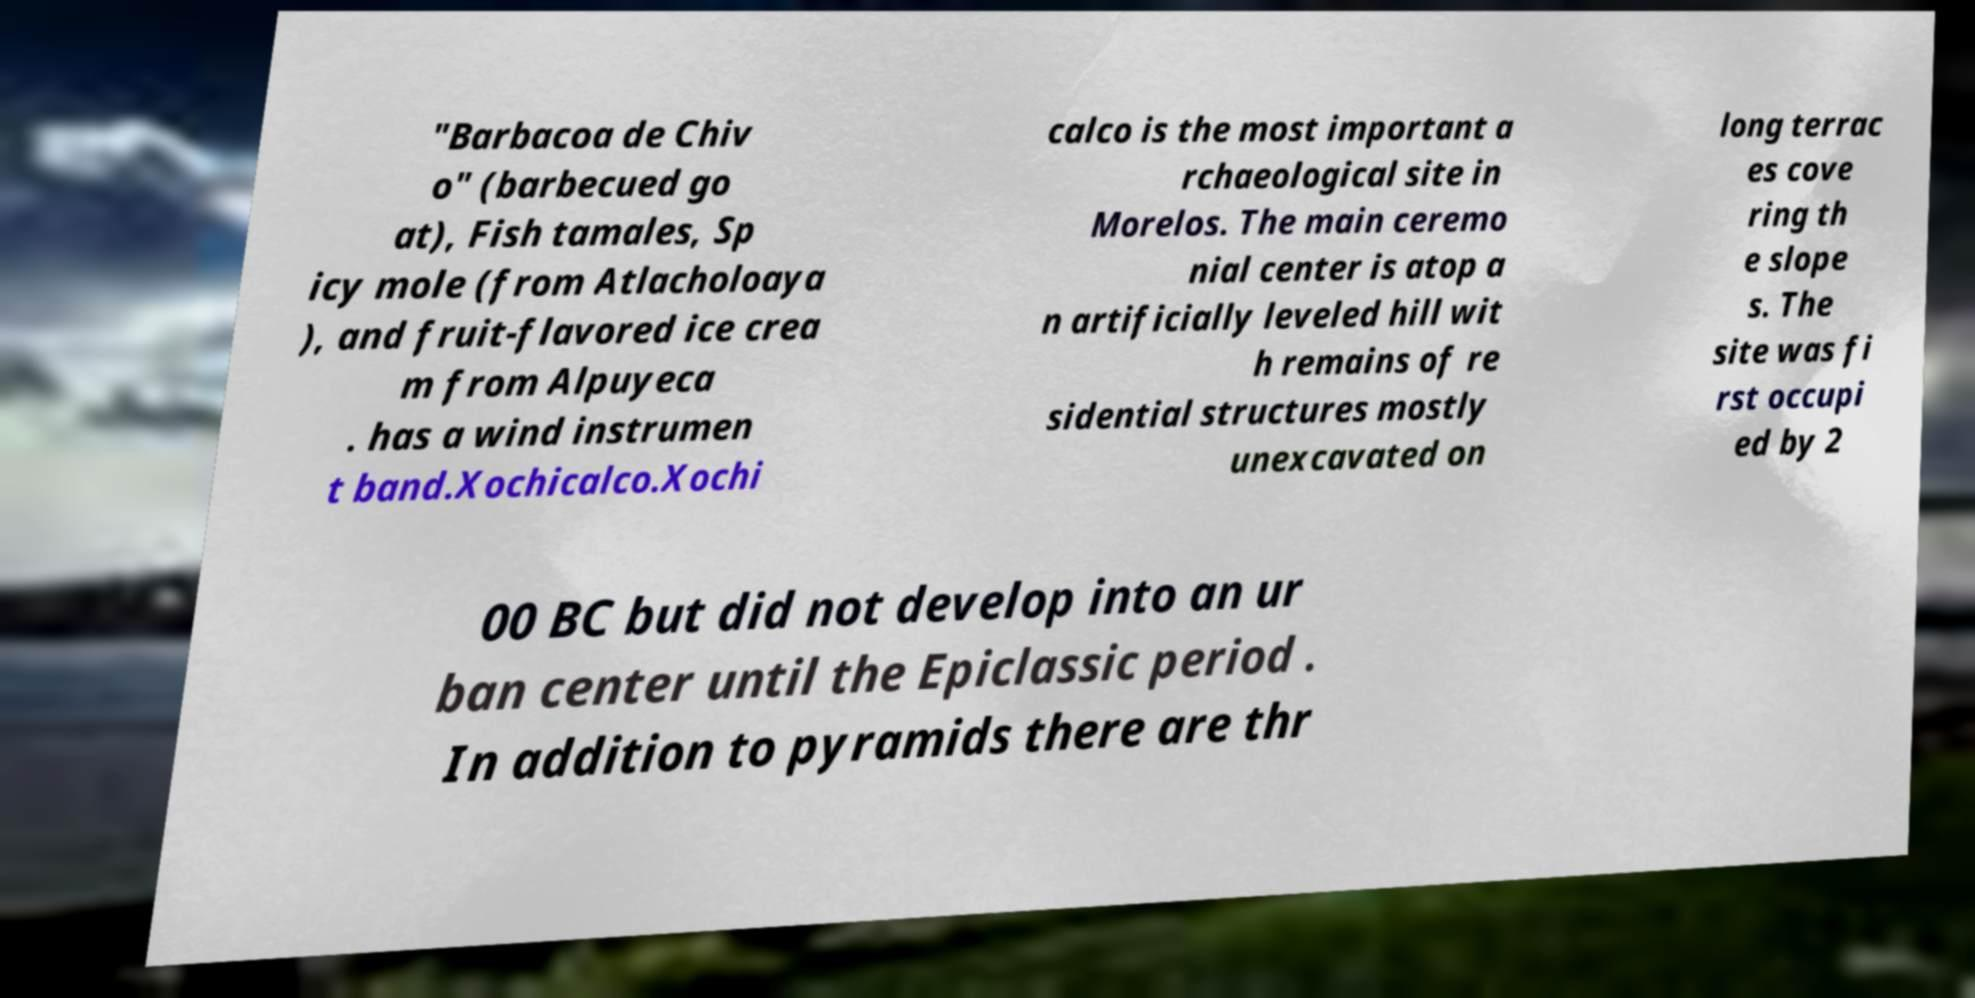What messages or text are displayed in this image? I need them in a readable, typed format. "Barbacoa de Chiv o" (barbecued go at), Fish tamales, Sp icy mole (from Atlacholoaya ), and fruit-flavored ice crea m from Alpuyeca . has a wind instrumen t band.Xochicalco.Xochi calco is the most important a rchaeological site in Morelos. The main ceremo nial center is atop a n artificially leveled hill wit h remains of re sidential structures mostly unexcavated on long terrac es cove ring th e slope s. The site was fi rst occupi ed by 2 00 BC but did not develop into an ur ban center until the Epiclassic period . In addition to pyramids there are thr 